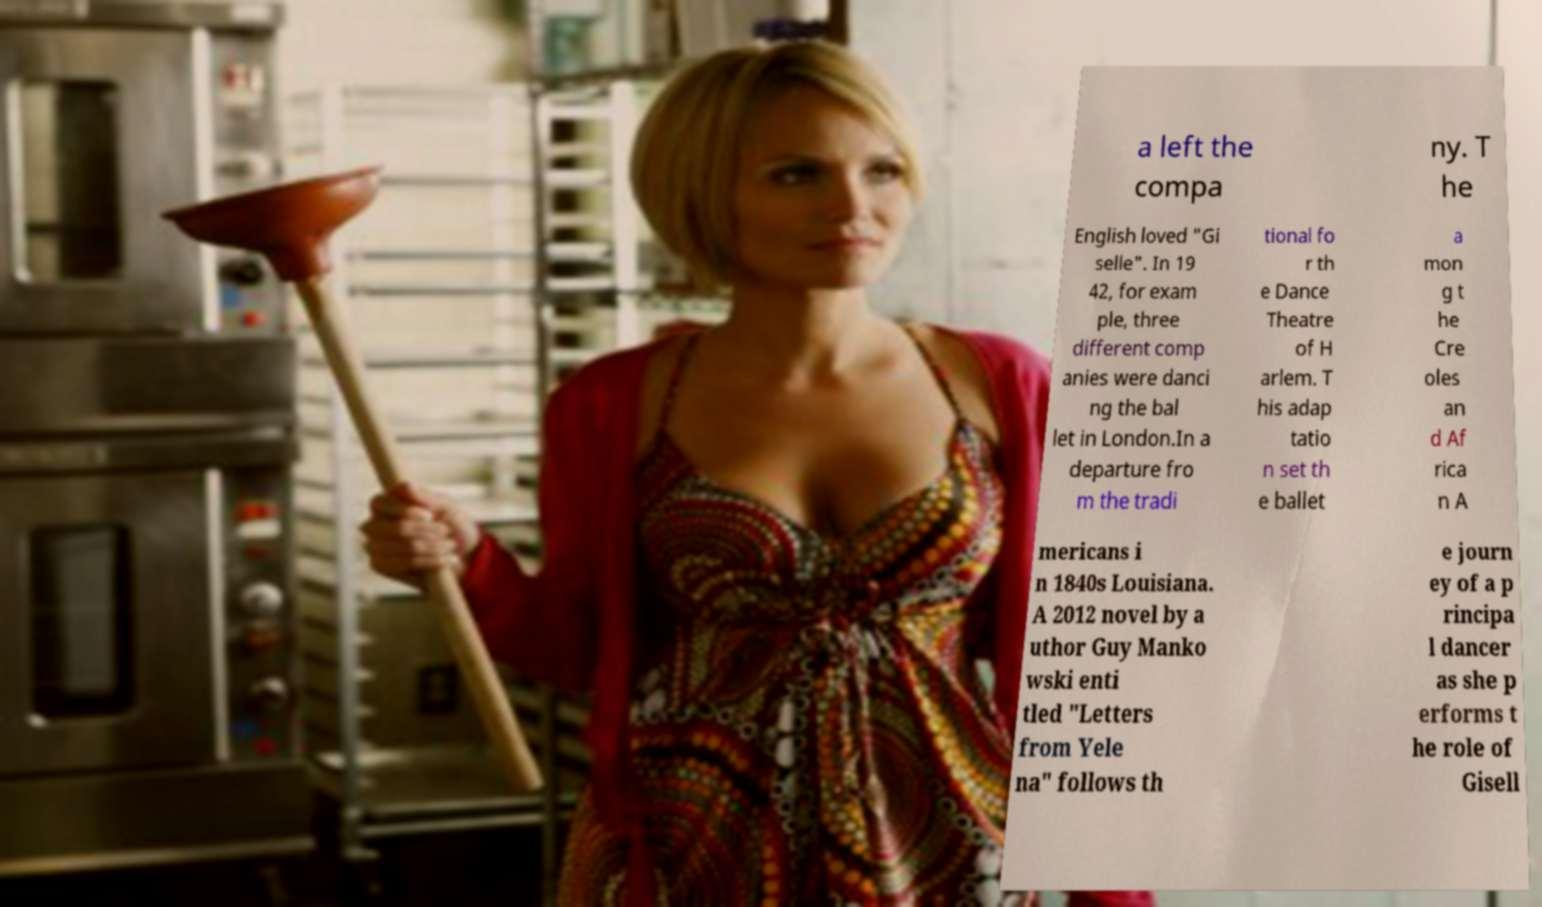Please read and relay the text visible in this image. What does it say? a left the compa ny. T he English loved "Gi selle". In 19 42, for exam ple, three different comp anies were danci ng the bal let in London.In a departure fro m the tradi tional fo r th e Dance Theatre of H arlem. T his adap tatio n set th e ballet a mon g t he Cre oles an d Af rica n A mericans i n 1840s Louisiana. A 2012 novel by a uthor Guy Manko wski enti tled "Letters from Yele na" follows th e journ ey of a p rincipa l dancer as she p erforms t he role of Gisell 